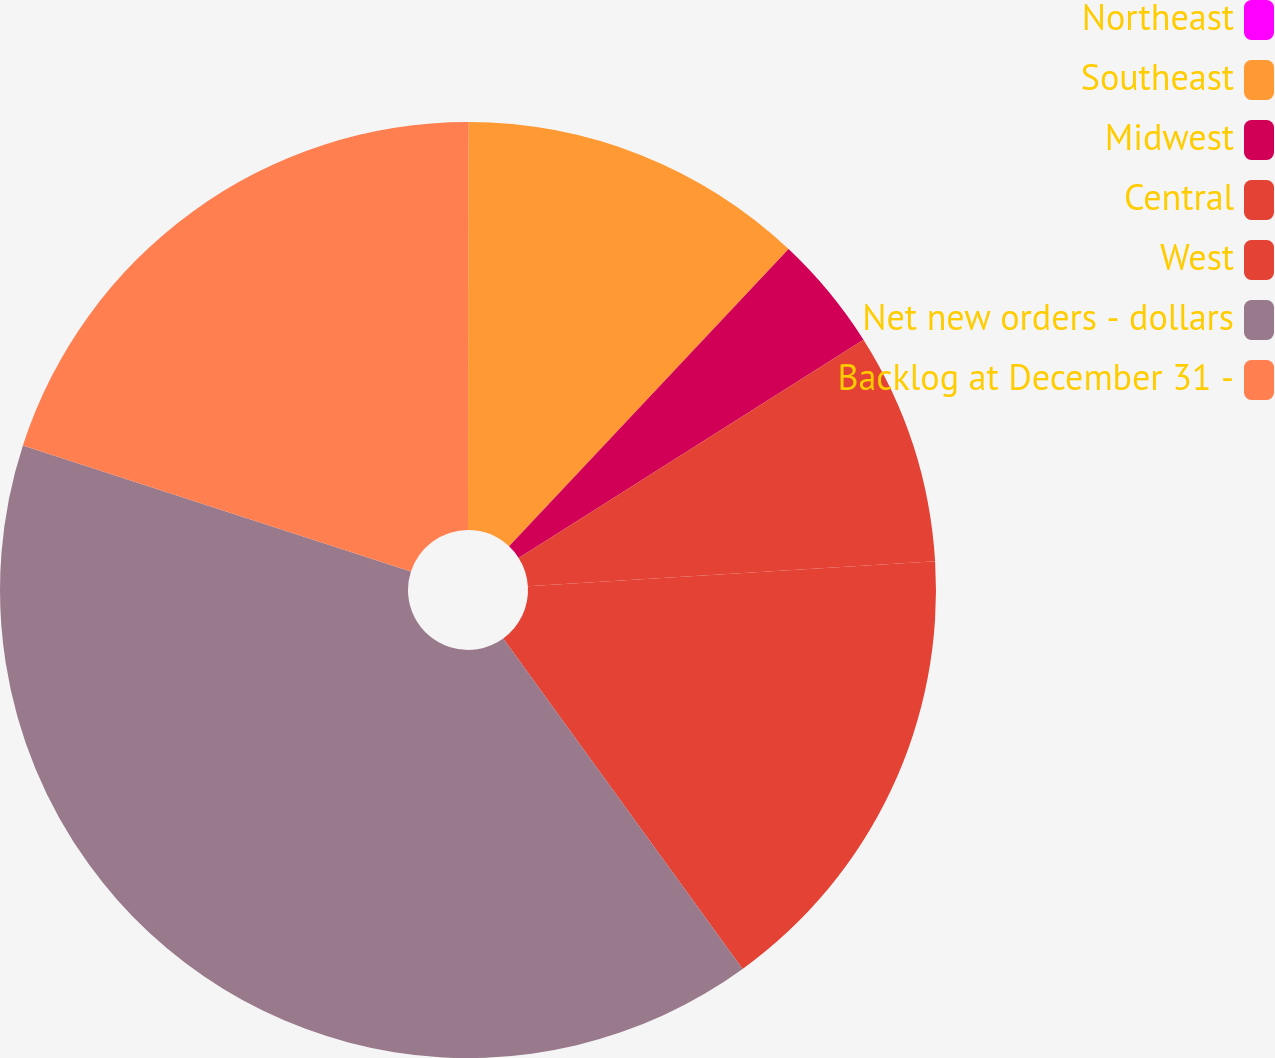Convert chart to OTSL. <chart><loc_0><loc_0><loc_500><loc_500><pie_chart><fcel>Northeast<fcel>Southeast<fcel>Midwest<fcel>Central<fcel>West<fcel>Net new orders - dollars<fcel>Backlog at December 31 -<nl><fcel>0.01%<fcel>12.0%<fcel>4.01%<fcel>8.0%<fcel>16.0%<fcel>39.98%<fcel>20.0%<nl></chart> 